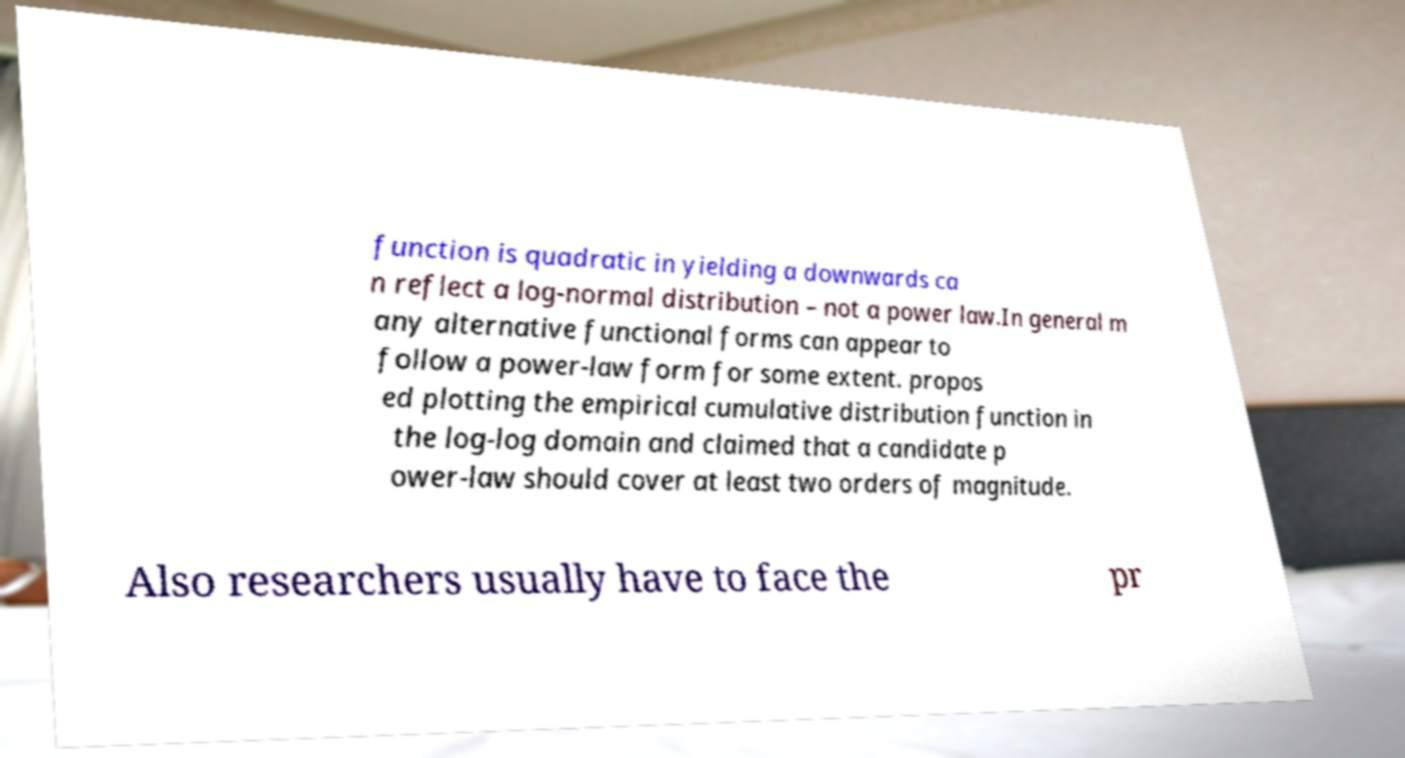Please read and relay the text visible in this image. What does it say? function is quadratic in yielding a downwards ca n reflect a log-normal distribution – not a power law.In general m any alternative functional forms can appear to follow a power-law form for some extent. propos ed plotting the empirical cumulative distribution function in the log-log domain and claimed that a candidate p ower-law should cover at least two orders of magnitude. Also researchers usually have to face the pr 